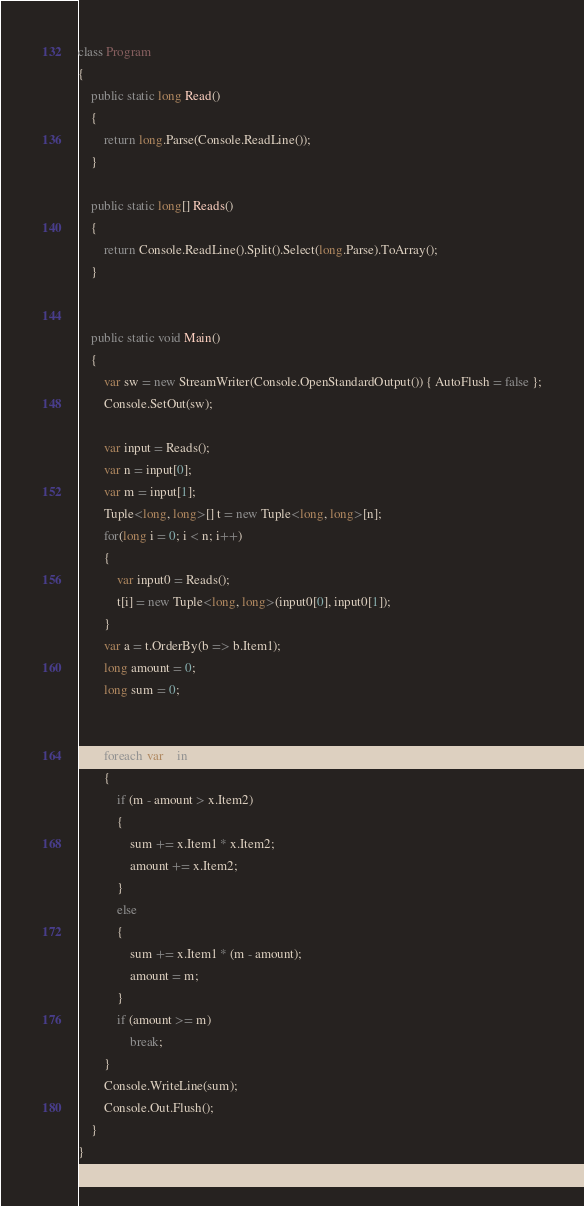<code> <loc_0><loc_0><loc_500><loc_500><_C#_>class Program
{
    public static long Read()
    {
        return long.Parse(Console.ReadLine());
    }

    public static long[] Reads()
    {
        return Console.ReadLine().Split().Select(long.Parse).ToArray();
    }


    public static void Main()
    {
        var sw = new StreamWriter(Console.OpenStandardOutput()) { AutoFlush = false };
        Console.SetOut(sw);

        var input = Reads();
        var n = input[0];
        var m = input[1];
        Tuple<long, long>[] t = new Tuple<long, long>[n];
        for(long i = 0; i < n; i++)
        {
            var input0 = Reads();
            t[i] = new Tuple<long, long>(input0[0], input0[1]);
        }
        var a = t.OrderBy(b => b.Item1);
        long amount = 0;
        long sum = 0;


        foreach(var x in a)
        {
            if (m - amount > x.Item2)
            {
                sum += x.Item1 * x.Item2;
                amount += x.Item2;
            }
            else
            {
                sum += x.Item1 * (m - amount);
                amount = m;
            }
            if (amount >= m)
                break;
        }
        Console.WriteLine(sum);
        Console.Out.Flush();
    }
}</code> 